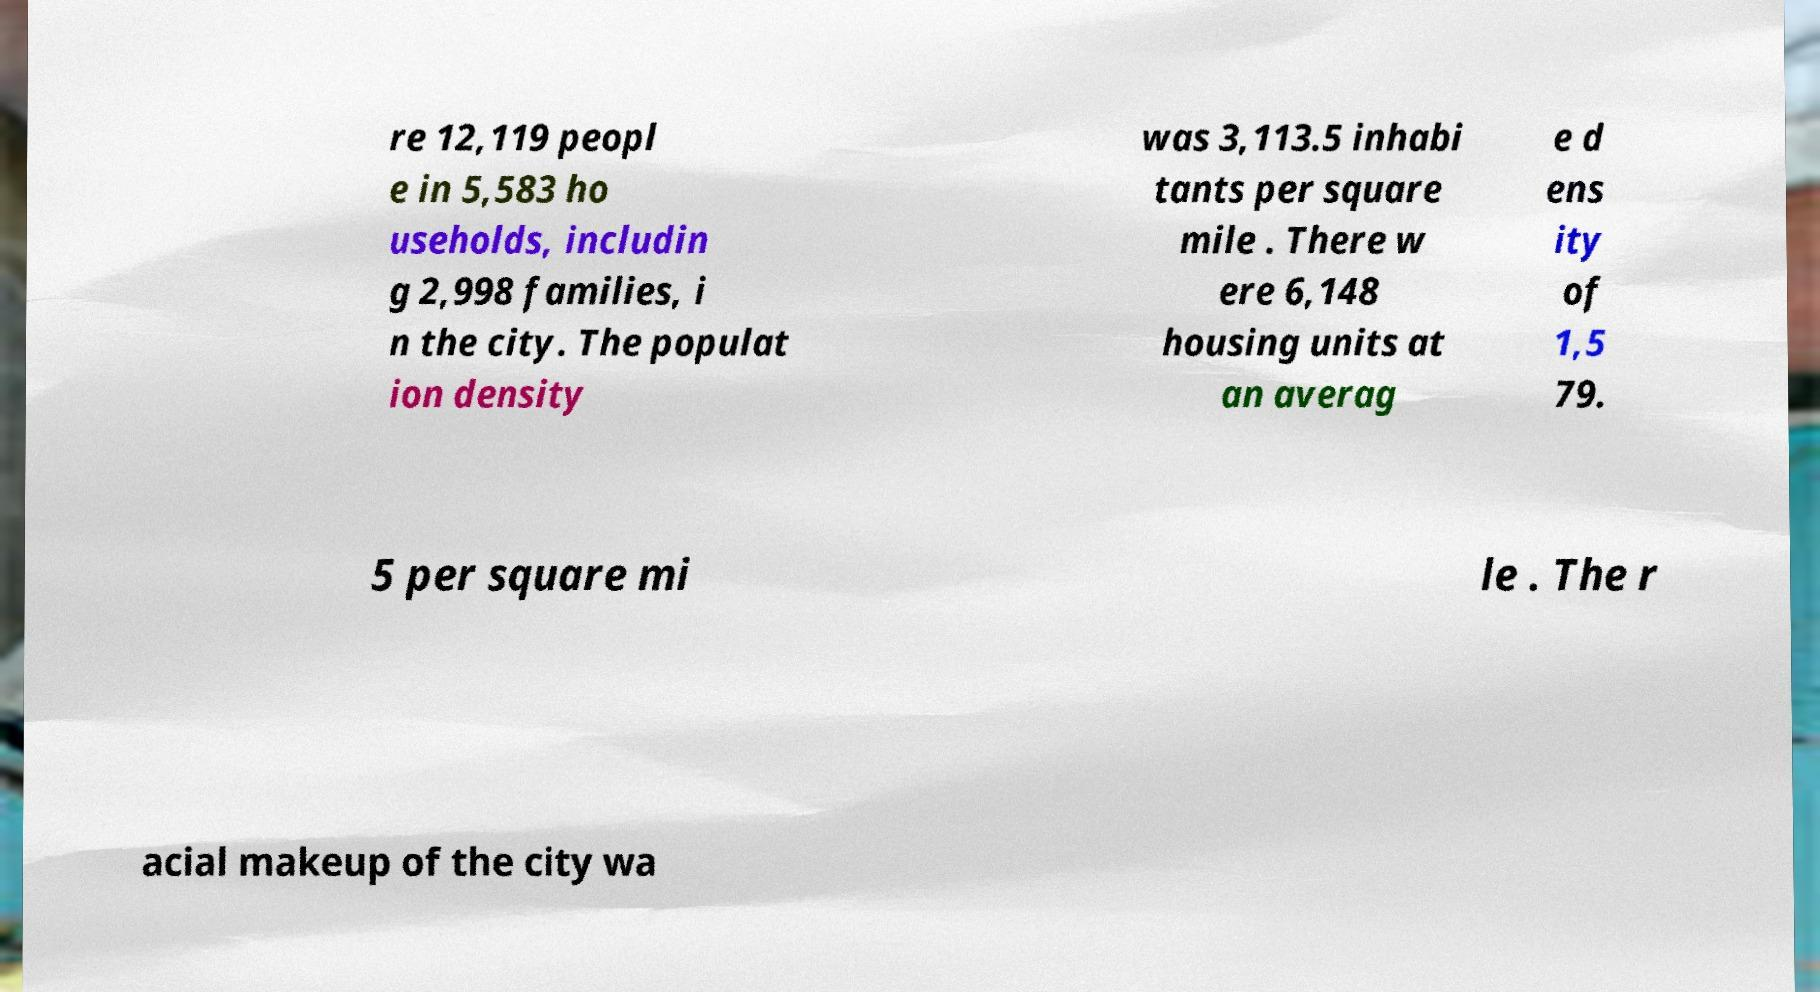For documentation purposes, I need the text within this image transcribed. Could you provide that? re 12,119 peopl e in 5,583 ho useholds, includin g 2,998 families, i n the city. The populat ion density was 3,113.5 inhabi tants per square mile . There w ere 6,148 housing units at an averag e d ens ity of 1,5 79. 5 per square mi le . The r acial makeup of the city wa 